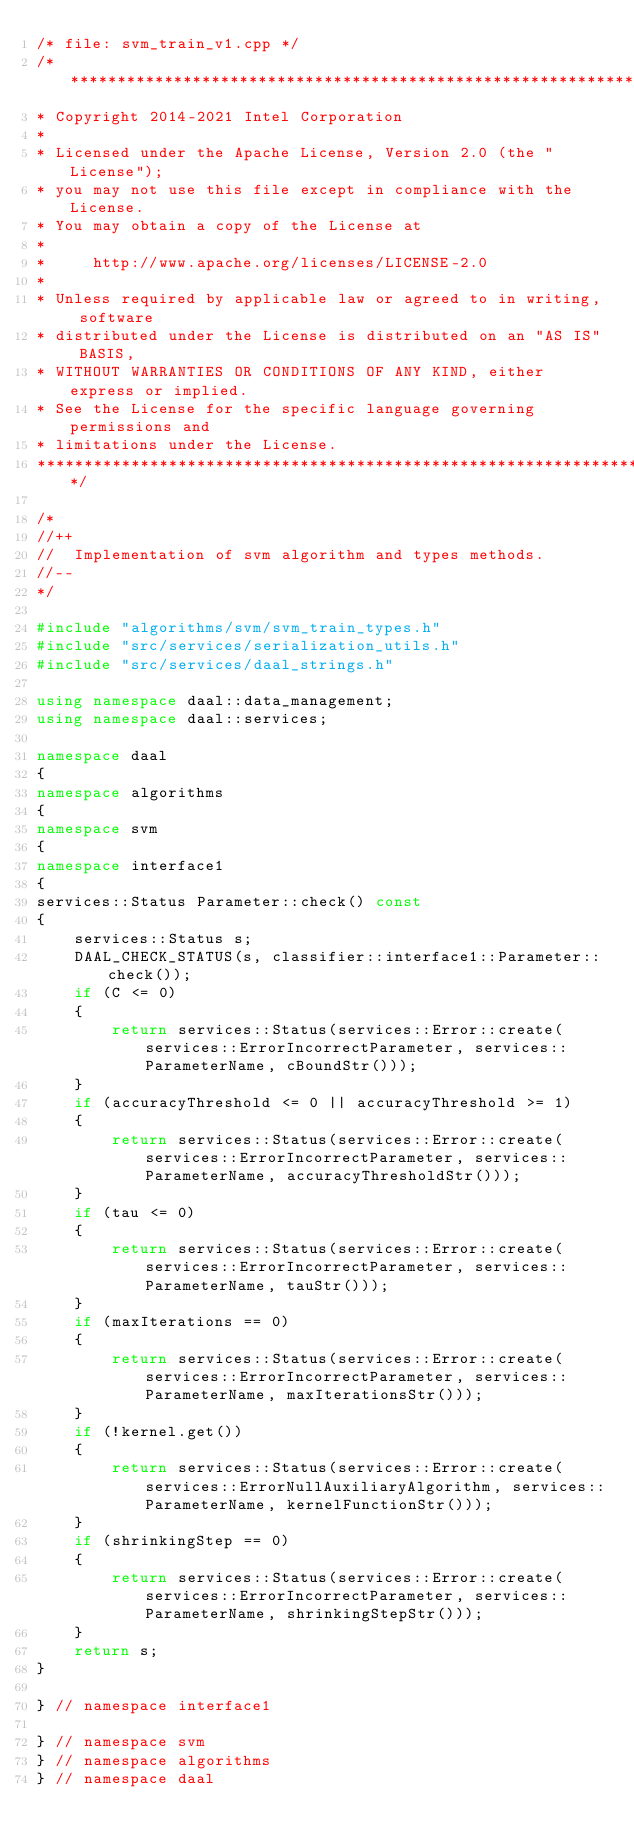Convert code to text. <code><loc_0><loc_0><loc_500><loc_500><_C++_>/* file: svm_train_v1.cpp */
/*******************************************************************************
* Copyright 2014-2021 Intel Corporation
*
* Licensed under the Apache License, Version 2.0 (the "License");
* you may not use this file except in compliance with the License.
* You may obtain a copy of the License at
*
*     http://www.apache.org/licenses/LICENSE-2.0
*
* Unless required by applicable law or agreed to in writing, software
* distributed under the License is distributed on an "AS IS" BASIS,
* WITHOUT WARRANTIES OR CONDITIONS OF ANY KIND, either express or implied.
* See the License for the specific language governing permissions and
* limitations under the License.
*******************************************************************************/

/*
//++
//  Implementation of svm algorithm and types methods.
//--
*/

#include "algorithms/svm/svm_train_types.h"
#include "src/services/serialization_utils.h"
#include "src/services/daal_strings.h"

using namespace daal::data_management;
using namespace daal::services;

namespace daal
{
namespace algorithms
{
namespace svm
{
namespace interface1
{
services::Status Parameter::check() const
{
    services::Status s;
    DAAL_CHECK_STATUS(s, classifier::interface1::Parameter::check());
    if (C <= 0)
    {
        return services::Status(services::Error::create(services::ErrorIncorrectParameter, services::ParameterName, cBoundStr()));
    }
    if (accuracyThreshold <= 0 || accuracyThreshold >= 1)
    {
        return services::Status(services::Error::create(services::ErrorIncorrectParameter, services::ParameterName, accuracyThresholdStr()));
    }
    if (tau <= 0)
    {
        return services::Status(services::Error::create(services::ErrorIncorrectParameter, services::ParameterName, tauStr()));
    }
    if (maxIterations == 0)
    {
        return services::Status(services::Error::create(services::ErrorIncorrectParameter, services::ParameterName, maxIterationsStr()));
    }
    if (!kernel.get())
    {
        return services::Status(services::Error::create(services::ErrorNullAuxiliaryAlgorithm, services::ParameterName, kernelFunctionStr()));
    }
    if (shrinkingStep == 0)
    {
        return services::Status(services::Error::create(services::ErrorIncorrectParameter, services::ParameterName, shrinkingStepStr()));
    }
    return s;
}

} // namespace interface1

} // namespace svm
} // namespace algorithms
} // namespace daal
</code> 